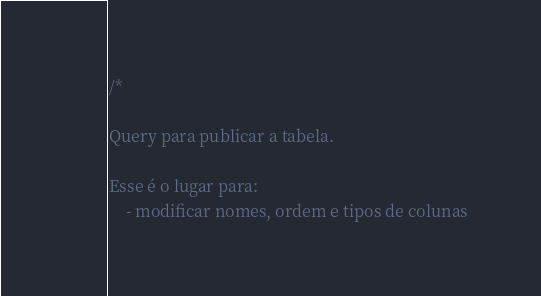Convert code to text. <code><loc_0><loc_0><loc_500><loc_500><_SQL_>/*

Query para publicar a tabela.

Esse é o lugar para:
    - modificar nomes, ordem e tipos de colunas</code> 